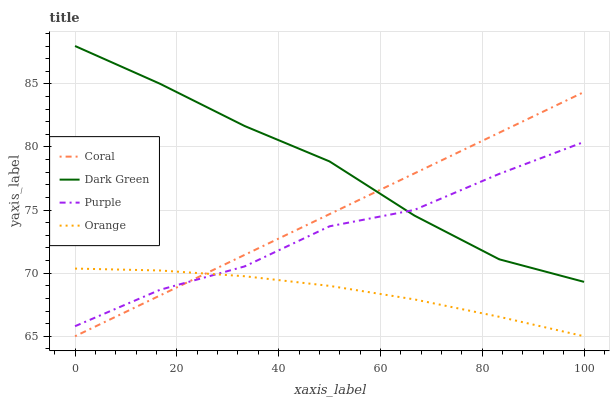Does Orange have the minimum area under the curve?
Answer yes or no. Yes. Does Dark Green have the maximum area under the curve?
Answer yes or no. Yes. Does Coral have the minimum area under the curve?
Answer yes or no. No. Does Coral have the maximum area under the curve?
Answer yes or no. No. Is Coral the smoothest?
Answer yes or no. Yes. Is Purple the roughest?
Answer yes or no. Yes. Is Orange the smoothest?
Answer yes or no. No. Is Orange the roughest?
Answer yes or no. No. Does Orange have the lowest value?
Answer yes or no. Yes. Does Dark Green have the lowest value?
Answer yes or no. No. Does Dark Green have the highest value?
Answer yes or no. Yes. Does Coral have the highest value?
Answer yes or no. No. Is Orange less than Dark Green?
Answer yes or no. Yes. Is Dark Green greater than Orange?
Answer yes or no. Yes. Does Dark Green intersect Purple?
Answer yes or no. Yes. Is Dark Green less than Purple?
Answer yes or no. No. Is Dark Green greater than Purple?
Answer yes or no. No. Does Orange intersect Dark Green?
Answer yes or no. No. 